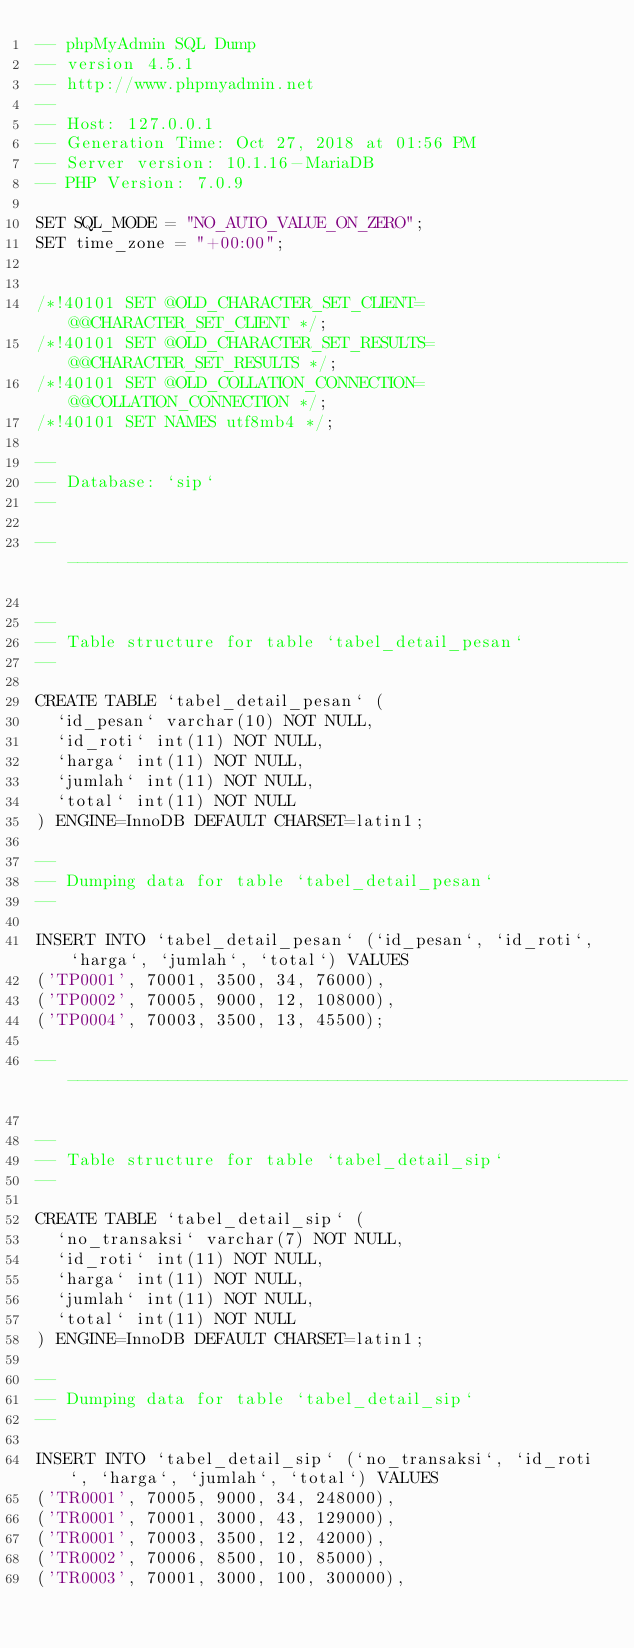<code> <loc_0><loc_0><loc_500><loc_500><_SQL_>-- phpMyAdmin SQL Dump
-- version 4.5.1
-- http://www.phpmyadmin.net
--
-- Host: 127.0.0.1
-- Generation Time: Oct 27, 2018 at 01:56 PM
-- Server version: 10.1.16-MariaDB
-- PHP Version: 7.0.9

SET SQL_MODE = "NO_AUTO_VALUE_ON_ZERO";
SET time_zone = "+00:00";


/*!40101 SET @OLD_CHARACTER_SET_CLIENT=@@CHARACTER_SET_CLIENT */;
/*!40101 SET @OLD_CHARACTER_SET_RESULTS=@@CHARACTER_SET_RESULTS */;
/*!40101 SET @OLD_COLLATION_CONNECTION=@@COLLATION_CONNECTION */;
/*!40101 SET NAMES utf8mb4 */;

--
-- Database: `sip`
--

-- --------------------------------------------------------

--
-- Table structure for table `tabel_detail_pesan`
--

CREATE TABLE `tabel_detail_pesan` (
  `id_pesan` varchar(10) NOT NULL,
  `id_roti` int(11) NOT NULL,
  `harga` int(11) NOT NULL,
  `jumlah` int(11) NOT NULL,
  `total` int(11) NOT NULL
) ENGINE=InnoDB DEFAULT CHARSET=latin1;

--
-- Dumping data for table `tabel_detail_pesan`
--

INSERT INTO `tabel_detail_pesan` (`id_pesan`, `id_roti`, `harga`, `jumlah`, `total`) VALUES
('TP0001', 70001, 3500, 34, 76000),
('TP0002', 70005, 9000, 12, 108000),
('TP0004', 70003, 3500, 13, 45500);

-- --------------------------------------------------------

--
-- Table structure for table `tabel_detail_sip`
--

CREATE TABLE `tabel_detail_sip` (
  `no_transaksi` varchar(7) NOT NULL,
  `id_roti` int(11) NOT NULL,
  `harga` int(11) NOT NULL,
  `jumlah` int(11) NOT NULL,
  `total` int(11) NOT NULL
) ENGINE=InnoDB DEFAULT CHARSET=latin1;

--
-- Dumping data for table `tabel_detail_sip`
--

INSERT INTO `tabel_detail_sip` (`no_transaksi`, `id_roti`, `harga`, `jumlah`, `total`) VALUES
('TR0001', 70005, 9000, 34, 248000),
('TR0001', 70001, 3000, 43, 129000),
('TR0001', 70003, 3500, 12, 42000),
('TR0002', 70006, 8500, 10, 85000),
('TR0003', 70001, 3000, 100, 300000),</code> 